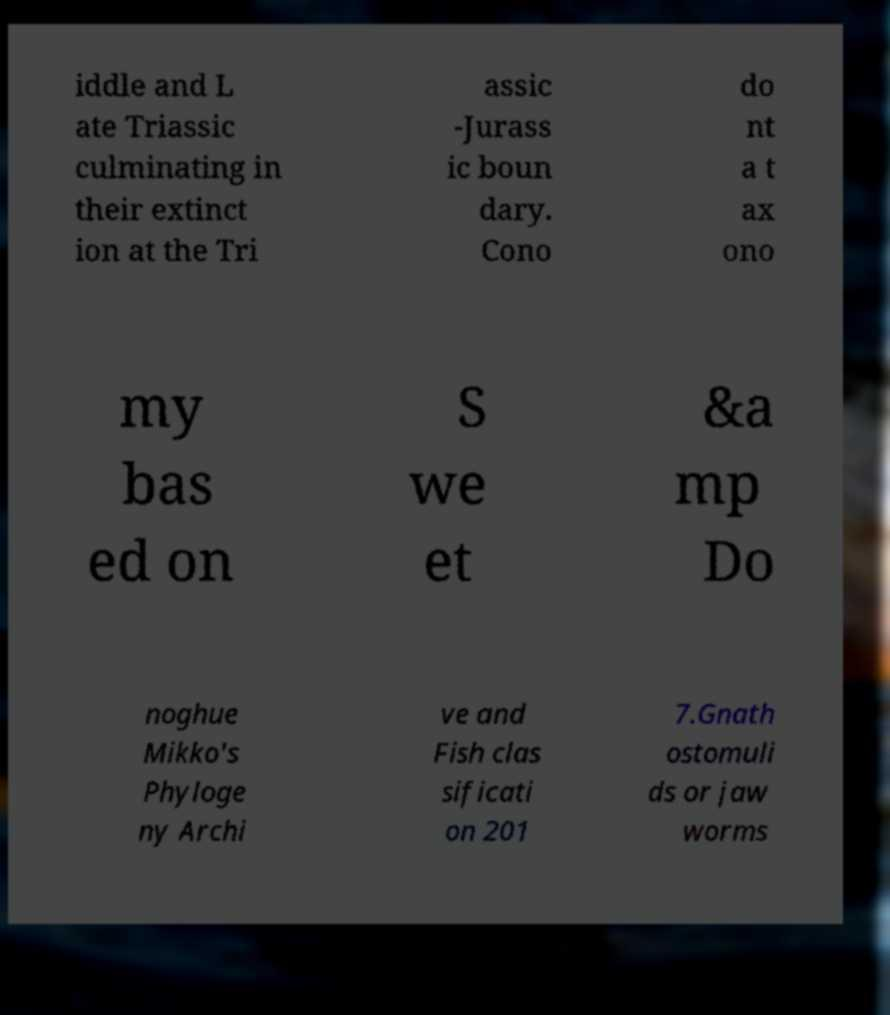Can you read and provide the text displayed in the image?This photo seems to have some interesting text. Can you extract and type it out for me? iddle and L ate Triassic culminating in their extinct ion at the Tri assic -Jurass ic boun dary. Cono do nt a t ax ono my bas ed on S we et &a mp Do noghue Mikko's Phyloge ny Archi ve and Fish clas sificati on 201 7.Gnath ostomuli ds or jaw worms 